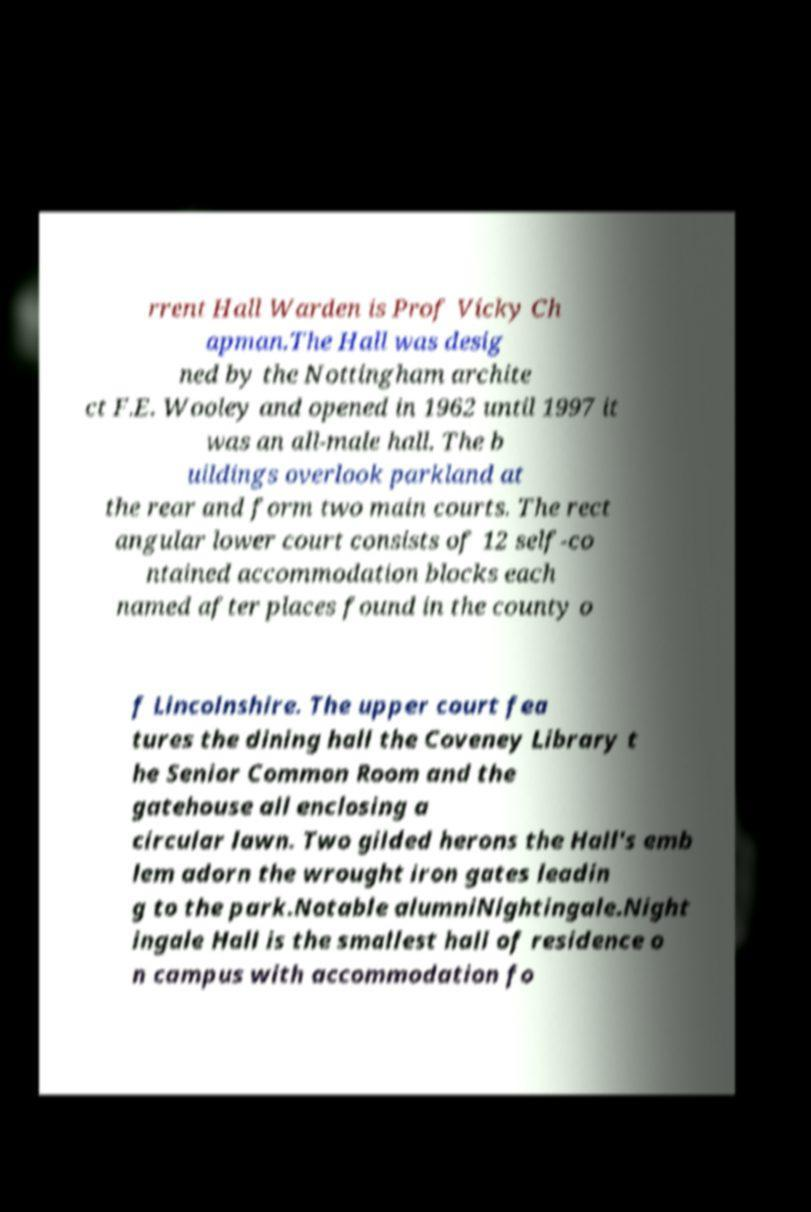Can you read and provide the text displayed in the image?This photo seems to have some interesting text. Can you extract and type it out for me? rrent Hall Warden is Prof Vicky Ch apman.The Hall was desig ned by the Nottingham archite ct F.E. Wooley and opened in 1962 until 1997 it was an all-male hall. The b uildings overlook parkland at the rear and form two main courts. The rect angular lower court consists of 12 self-co ntained accommodation blocks each named after places found in the county o f Lincolnshire. The upper court fea tures the dining hall the Coveney Library t he Senior Common Room and the gatehouse all enclosing a circular lawn. Two gilded herons the Hall's emb lem adorn the wrought iron gates leadin g to the park.Notable alumniNightingale.Night ingale Hall is the smallest hall of residence o n campus with accommodation fo 